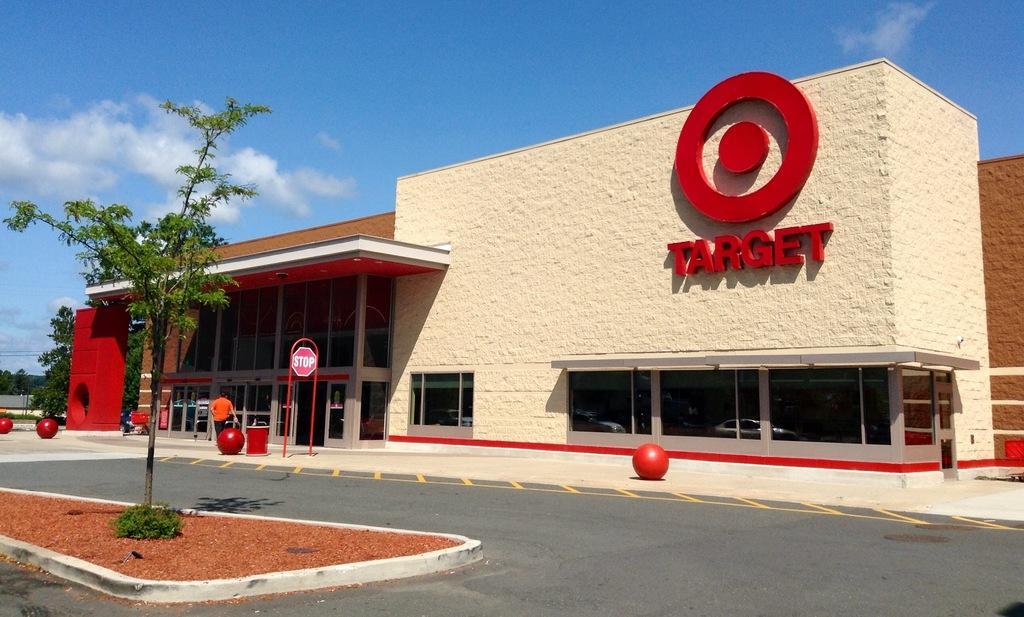How would you summarize this image in a sentence or two? In this image I can see the road, a tree which is green in color, few red colored objects on the ground, a person standing and a huge building which is cream, red and brown in color. In the background I can see few trees and the sky. 